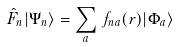Convert formula to latex. <formula><loc_0><loc_0><loc_500><loc_500>\hat { F } _ { n } | \Psi _ { n } \rangle = \sum _ { a } \, f _ { n a } ( r ) | \Phi _ { a } \rangle</formula> 